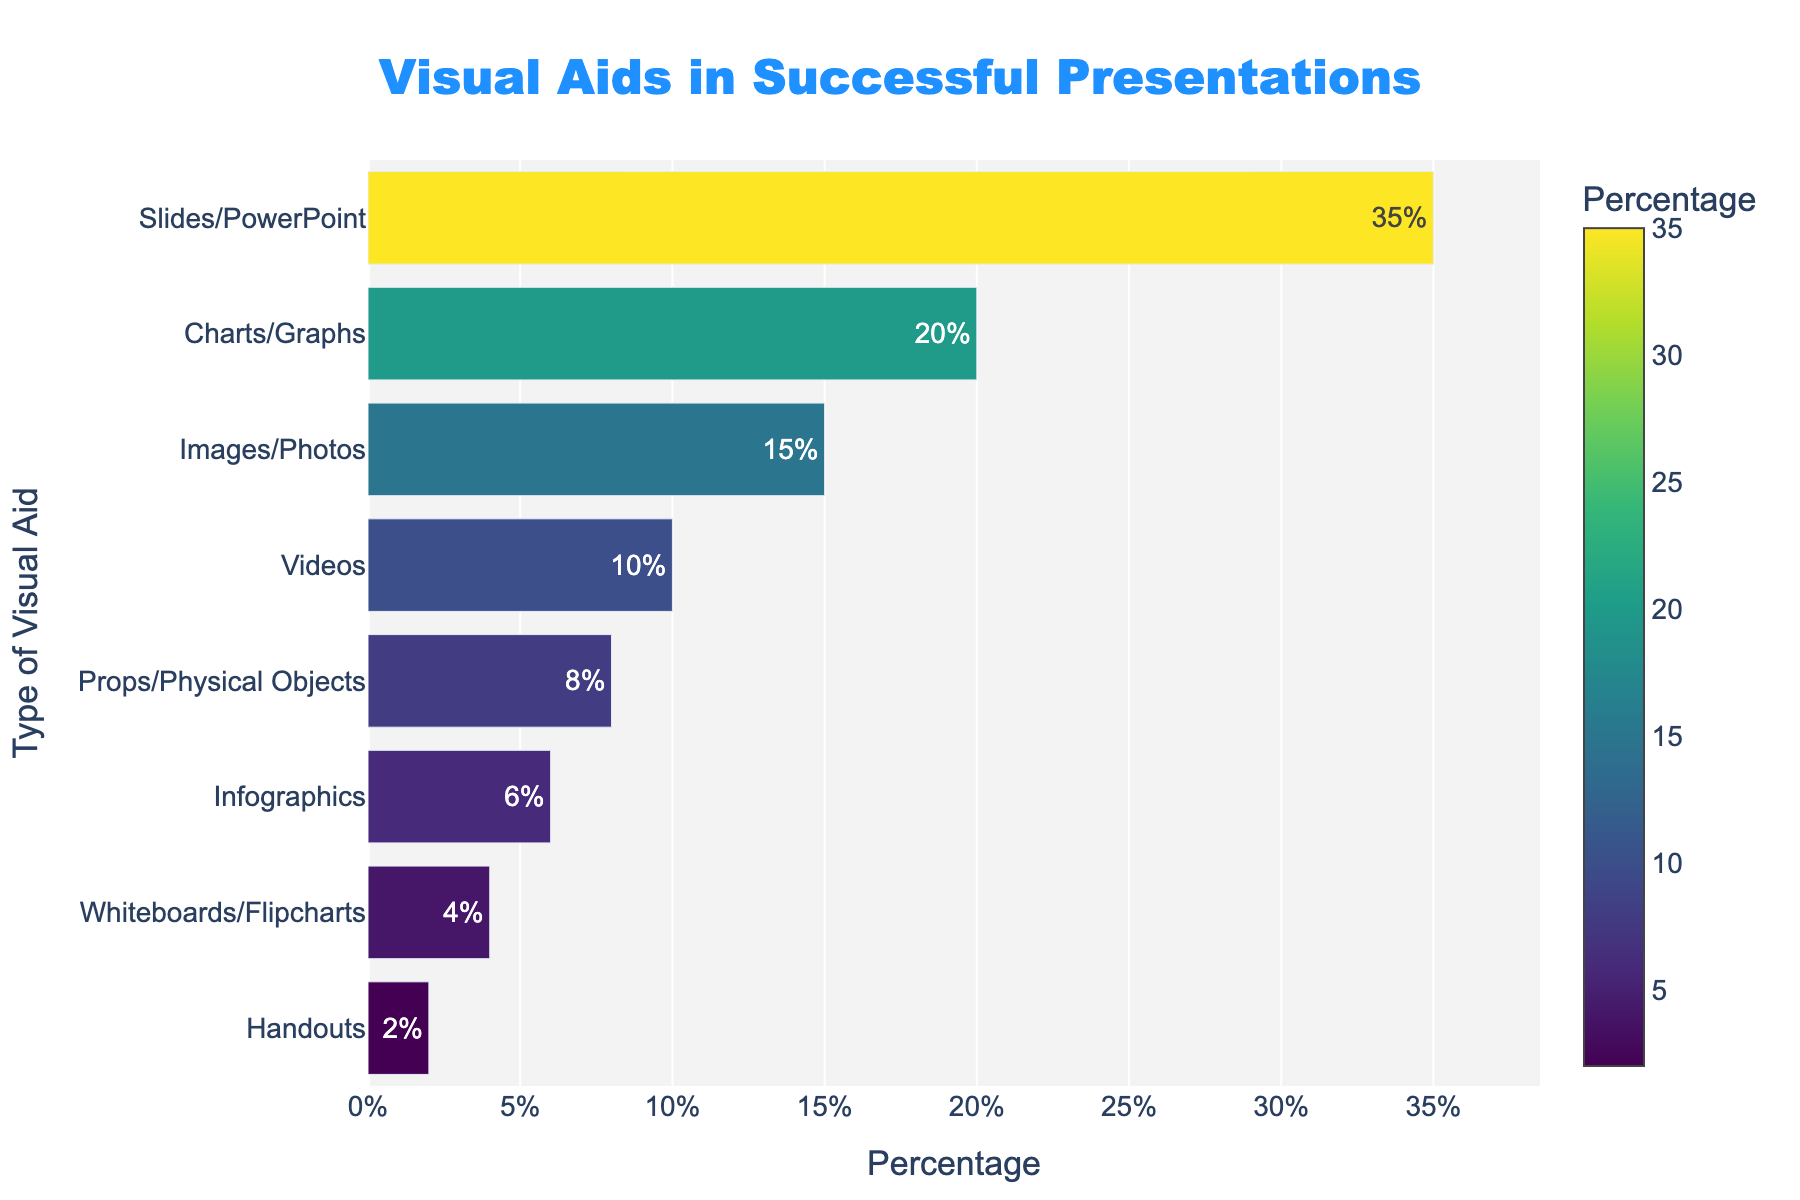Which type of visual aid is used the most in successful presentations? The bar for Slides/PowerPoint is the tallest, indicating it has the highest percentage.
Answer: Slides/PowerPoint What is the percentage breakdown for Charts/Graphs and Videos combined? Charts/Graphs have 20% and Videos have 10%. Adding them together gives 20% + 10% = 30%.
Answer: 30% How does the use of Props/Physical Objects compare to the use of Infographics in successful presentations? The percentage for Props/Physical Objects is 8%, while for Infographics it is 6%. Props/Physical Objects are used more than Infographics.
Answer: Props/Physical Objects are used more Which visual aid has the least usage percentage? The bar for Handouts is the shortest, indicating it has the lowest percentage at 2%.
Answer: Handouts What is the aggregate percentage of all visual aids that have usage below 10%? Adding the percentages for Props/Physical Objects (8%), Infographics (6%), Whiteboards/Flipcharts (4%), and Handouts (2%): 8% + 6% + 4% + 2% = 20%.
Answer: 20% Is the percentage of Images/Photos higher or lower than Videos? Images/Photos have a percentage of 15%, while Videos have 10%. Therefore, Images/Photos have a higher percentage than Videos.
Answer: Higher What is the difference in percentage between Slides/PowerPoint and Charts/Graphs? Slides/PowerPoint have 35% and Charts/Graphs have 20%. The difference is 35% - 20% = 15%.
Answer: 15% What's the combined percentage of the top three most used visual aids? The top three visual aids are Slides/PowerPoint (35%), Charts/Graphs (20%), and Images/Photos (15%). Adding them together gives 35% + 20% + 15% = 70%.
Answer: 70% What color gradient represents the highest usage percentage in the chart? The color gradient used is Viridis, and the darkest (most intense) color in the gradient represents the highest usage percentage.
Answer: Darkest color Which visual aid has a usage percentage closer to the middle value compared to others? With percentages sorted in descending order, the middle values are Infographics (6%) and Props/Physical Objects (8%). Infographics is closer to the median value.
Answer: Infographics 